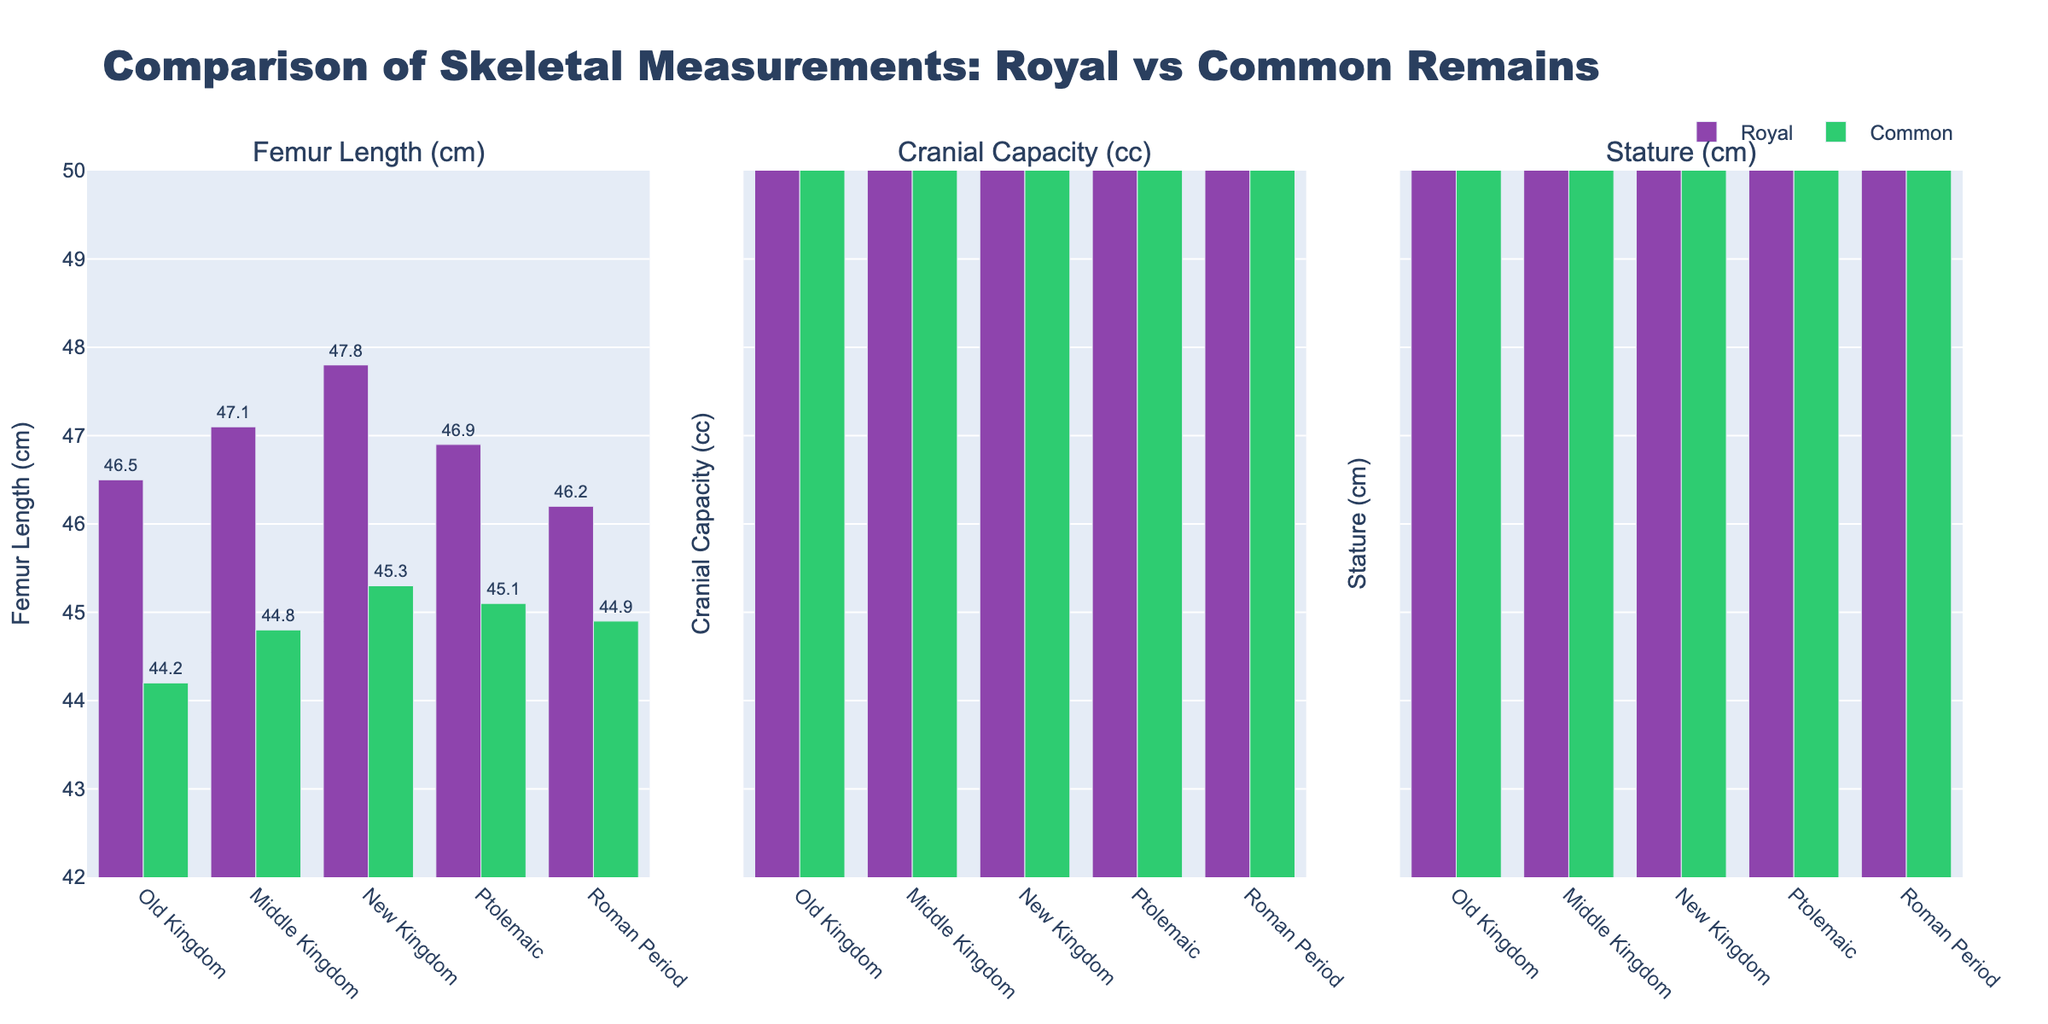What's the difference in femur length between royal and common remains in the New Kingdom? To find the difference, look at the bars for Femur Length (cm) in the New Kingdom category. The royal femur length is 47.8 cm and the common is 45.3 cm. The difference is 47.8 - 45.3 = 2.5 cm.
Answer: 2.5 cm Which dynasty has the smallest cranial capacity for royal remains? Inspect the Cranial Capacity (cc) subplot for all dynasties and focus on the royal category (indicated by color). The Old Kingdom shows the smallest cranial capacity for royal remains with 1480 cc.
Answer: Old Kingdom What's the average stature for common remains across all dynasties? Find the stature values for common remains in each dynasty: 166 (Old Kingdom), 168 (Middle Kingdom), 170 (New Kingdom), 169 (Ptolemaic), and 168 (Roman Period). The sum is 166 + 168 + 170 + 169 + 168 = 841. Dividing by the number of values (5), the average is 841 / 5 = 168.2 cm.
Answer: 168.2 cm Compare the cranial capacities between royal and common remains in the Middle Kingdom. Which one is greater and by how much? For the Middle Kingdom, the cranial capacity for royal remains is 1490 cc and for common remains is 1425 cc. The difference is 1490 - 1425 = 65 cc; royal is greater than common by 65 cc.
Answer: Royal by 65 cc Which category's femur length shows the least variation among the dynasties? Examine the Femur Length (cm) subplot and note the royal and common femur lengths. Royal remains show less variation (values from 46.2 to 47.8 cm) compared to common remains (values from 44.2 to 45.3 cm).
Answer: Royal remains In which dynasty does the difference in stature between royal and common remains equal 4 cm? Check the Stature (cm) plot: 
- Old Kingdom: 172 - 166 = 6 cm 
- Middle Kingdom: 174 - 168 = 6 cm 
- New Kingdom: 176 - 170 = 6 cm 
- Ptolemaic: 173 - 169 = 4 cm 
- Roman Period: 171 - 168 = 3 cm. Thus, it’s the Ptolemaic dynasty.
Answer: Ptolemaic During which period do common remains have the highest femur length? Look at the Femur Length (cm) subplot for common remains. The New Kingdom has the highest femur length for common remains with 45.3 cm.
Answer: New Kingdom What is the total cranial capacity for royal remains across all dynasties combined? Sum cranial capacities for royal remains: 1480 (Old Kingdom), 1490 (Middle Kingdom), 1500 (New Kingdom), 1485 (Ptolemaic), 1475 (Roman Period). The total is 1480 + 1490 + 1500 + 1485 + 1475 = 7430 cc.
Answer: 7430 cc What is the median stature for royal remains? List the stature values for royal remains across dynasties: 172 (Old Kingdom), 174 (Middle Kingdom), 176 (New Kingdom), 173 (Ptolemaic), 171 (Roman Period). The median is the middle value, which is 173 cm.
Answer: 173 cm 